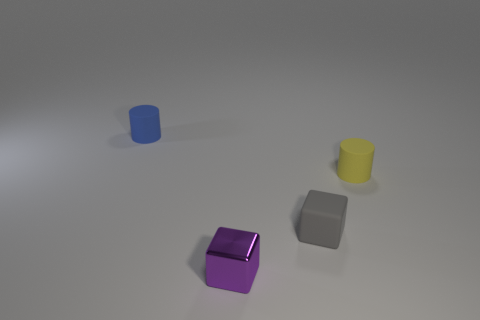Add 4 purple cylinders. How many objects exist? 8 Add 2 brown blocks. How many brown blocks exist? 2 Subtract 0 brown balls. How many objects are left? 4 Subtract all tiny yellow objects. Subtract all gray metallic blocks. How many objects are left? 3 Add 1 blue objects. How many blue objects are left? 2 